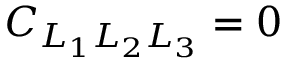<formula> <loc_0><loc_0><loc_500><loc_500>C _ { L _ { 1 } L _ { 2 } L _ { 3 } } = 0</formula> 